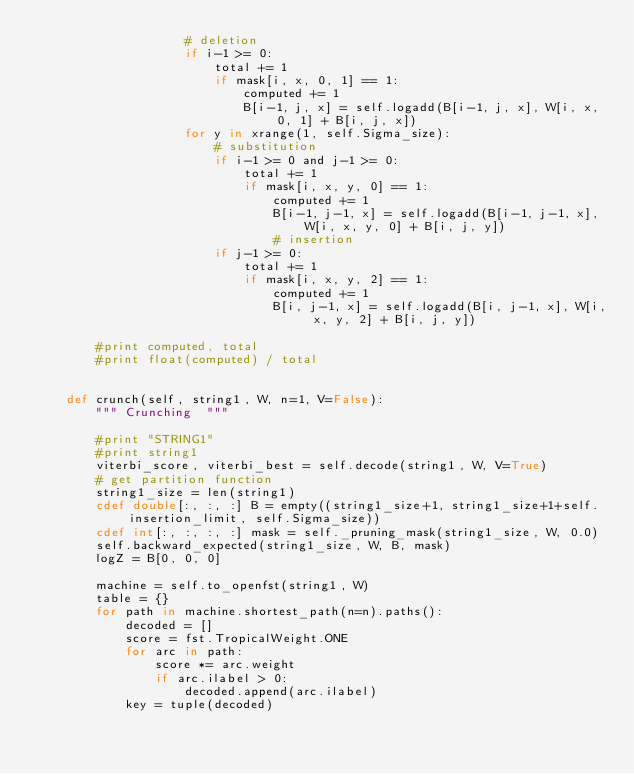Convert code to text. <code><loc_0><loc_0><loc_500><loc_500><_Cython_>                    # deletion
                    if i-1 >= 0:
                        total += 1
                        if mask[i, x, 0, 1] == 1:
                            computed += 1
                            B[i-1, j, x] = self.logadd(B[i-1, j, x], W[i, x, 0, 1] + B[i, j, x])
                    for y in xrange(1, self.Sigma_size):
                        # substitution
                        if i-1 >= 0 and j-1 >= 0:
                            total += 1
                            if mask[i, x, y, 0] == 1:
                                computed += 1
                                B[i-1, j-1, x] = self.logadd(B[i-1, j-1, x], W[i, x, y, 0] + B[i, j, y])
                                # insertion
                        if j-1 >= 0:
                            total += 1
                            if mask[i, x, y, 2] == 1:
                                computed += 1
                                B[i, j-1, x] = self.logadd(B[i, j-1, x], W[i, x, y, 2] + B[i, j, y])

        #print computed, total
        #print float(computed) / total

        
    def crunch(self, string1, W, n=1, V=False):
        """ Crunching  """

        #print "STRING1"
        #print string1
        viterbi_score, viterbi_best = self.decode(string1, W, V=True)
        # get partition function
        string1_size = len(string1)
        cdef double[:, :, :] B = empty((string1_size+1, string1_size+1+self.insertion_limit, self.Sigma_size))
        cdef int[:, :, :, :] mask = self._pruning_mask(string1_size, W, 0.0)
        self.backward_expected(string1_size, W, B, mask)
        logZ = B[0, 0, 0]

        machine = self.to_openfst(string1, W)
        table = {}
        for path in machine.shortest_path(n=n).paths():
            decoded = []
            score = fst.TropicalWeight.ONE
            for arc in path:
                score *= arc.weight
                if arc.ilabel > 0:
                    decoded.append(arc.ilabel)
            key = tuple(decoded)</code> 